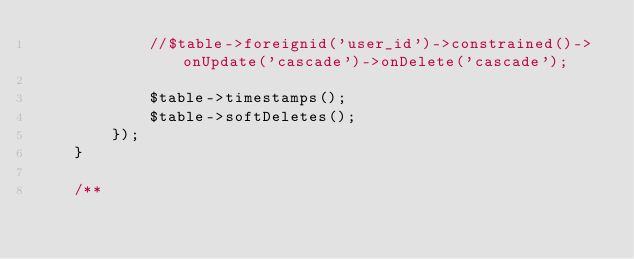<code> <loc_0><loc_0><loc_500><loc_500><_PHP_>            //$table->foreignid('user_id')->constrained()->onUpdate('cascade')->onDelete('cascade');

            $table->timestamps();
            $table->softDeletes();
        });
    }

    /**</code> 